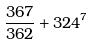<formula> <loc_0><loc_0><loc_500><loc_500>\frac { 3 6 7 } { 3 6 2 } + 3 2 4 ^ { 7 }</formula> 